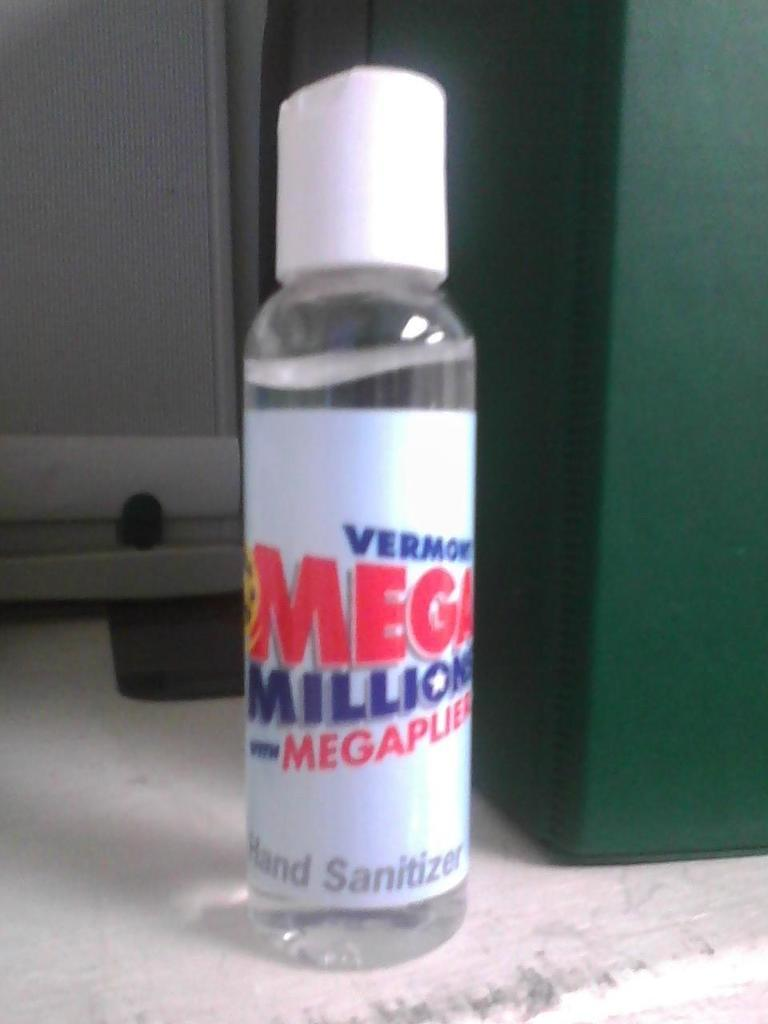<image>
Render a clear and concise summary of the photo. A bottle of Mega Millions hand sanitizer sits on a ledge. 